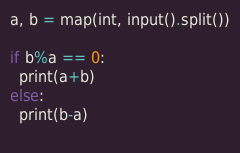Convert code to text. <code><loc_0><loc_0><loc_500><loc_500><_Python_>a, b = map(int, input().split())

if b%a == 0:
  print(a+b)
else:
  print(b-a)
  </code> 